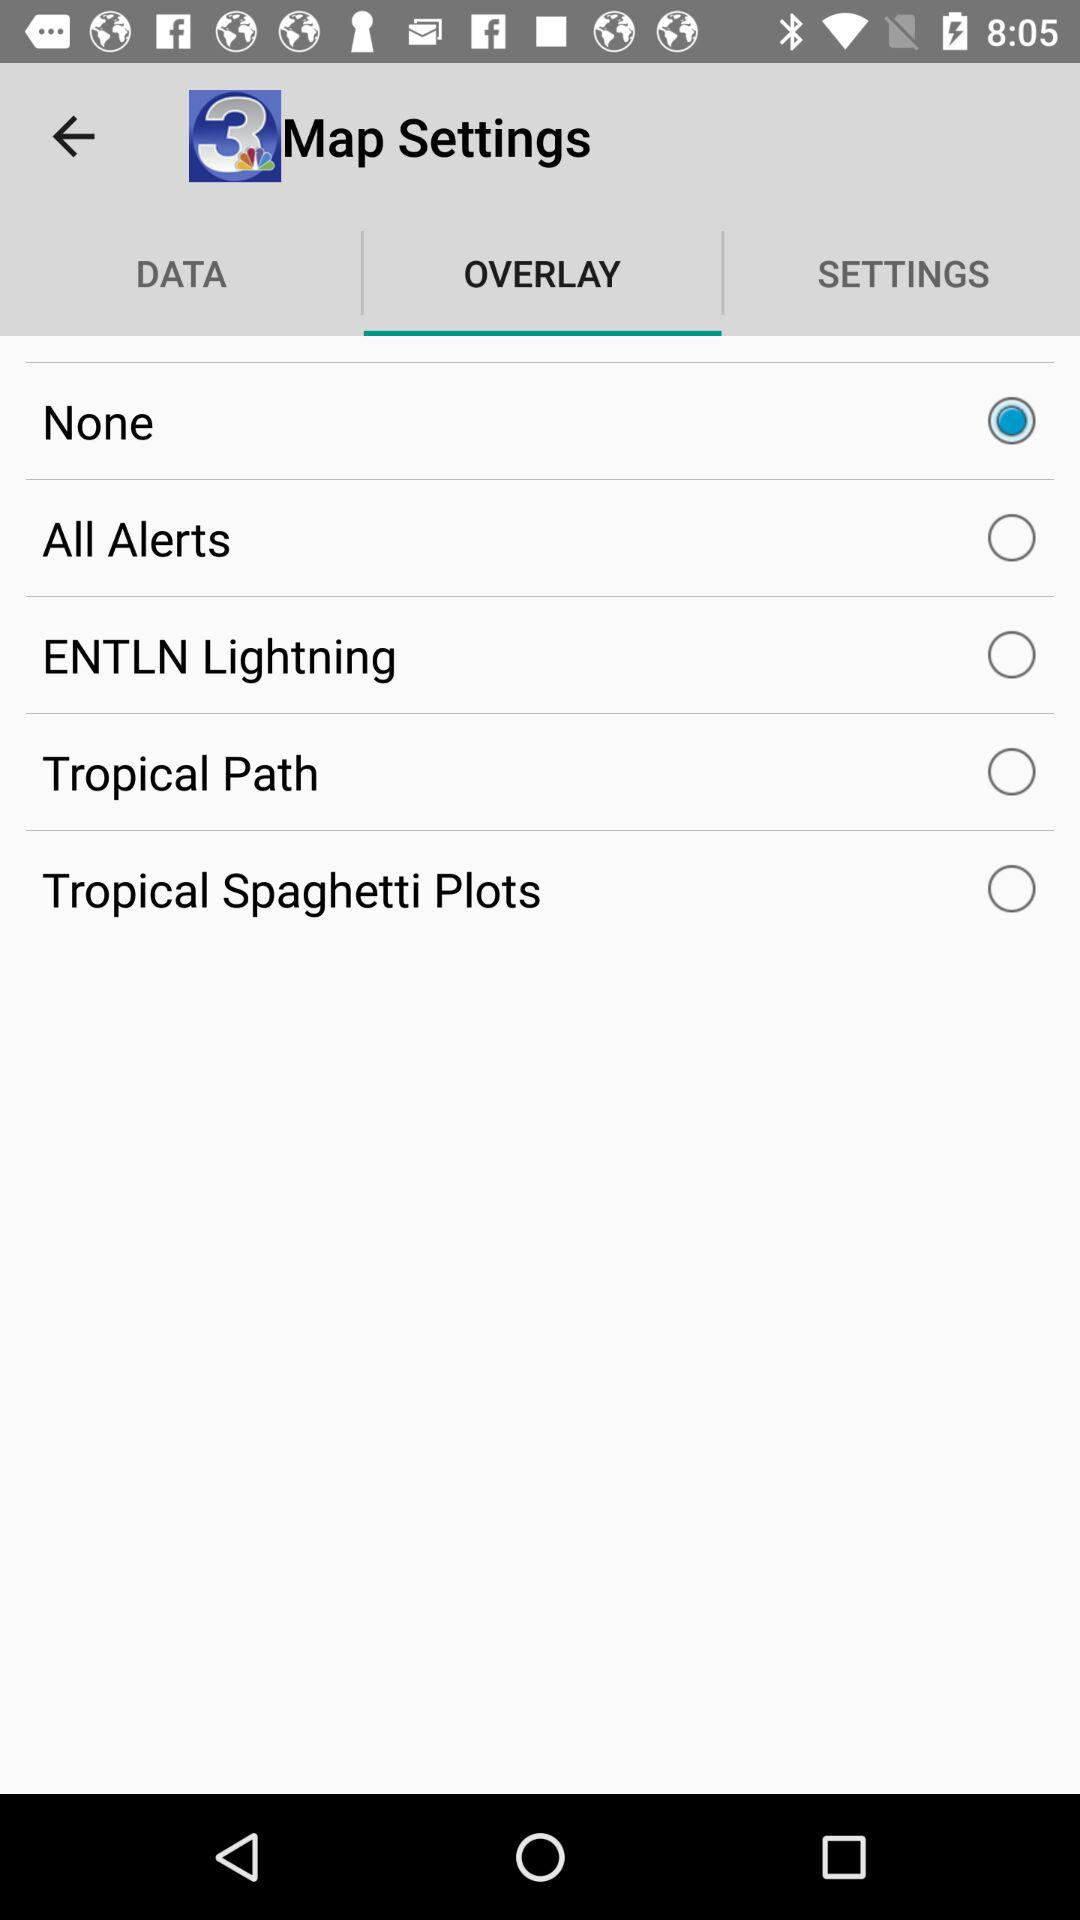Which option is selected in the application? The selected option is "None". 